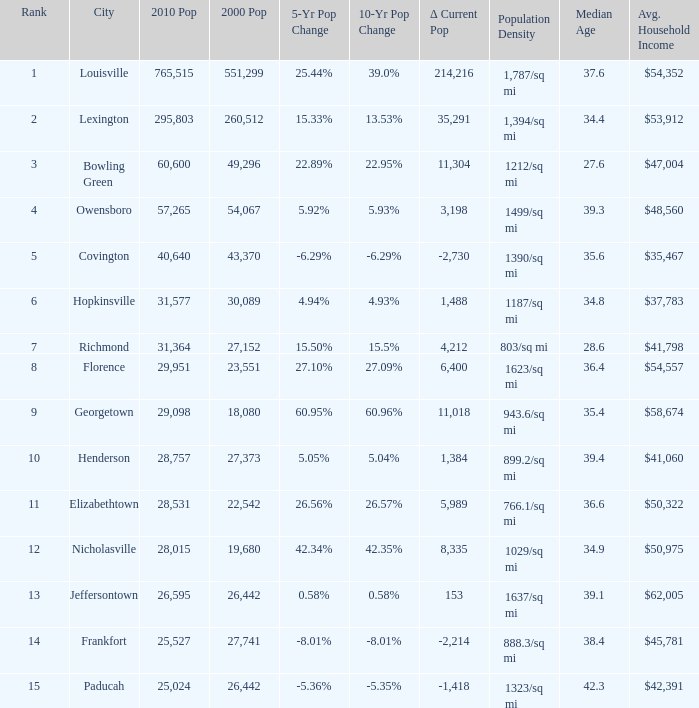What was the 2010 population of frankfort which has a rank smaller than 14? None. Could you help me parse every detail presented in this table? {'header': ['Rank', 'City', '2010 Pop', '2000 Pop', '5-Yr Pop Change', '10-Yr Pop Change', 'Δ Current Pop', 'Population Density', 'Median Age', 'Avg. Household Income '], 'rows': [['1', 'Louisville', '765,515', '551,299', '25.44%', '39.0%', '214,216', '1,787/sq mi', '37.6', '$54,352'], ['2', 'Lexington', '295,803', '260,512', '15.33%', '13.53%', '35,291', '1,394/sq mi', '34.4', '$53,912'], ['3', 'Bowling Green', '60,600', '49,296', '22.89%', '22.95%', '11,304', '1212/sq mi', '27.6', '$47,004'], ['4', 'Owensboro', '57,265', '54,067', '5.92%', '5.93%', '3,198', '1499/sq mi', '39.3', '$48,560'], ['5', 'Covington', '40,640', '43,370', '-6.29%', '-6.29%', '-2,730', '1390/sq mi', '35.6', '$35,467'], ['6', 'Hopkinsville', '31,577', '30,089', '4.94%', '4.93%', '1,488', '1187/sq mi', '34.8', '$37,783'], ['7', 'Richmond', '31,364', '27,152', '15.50%', '15.5%', '4,212', '803/sq mi', '28.6', '$41,798'], ['8', 'Florence', '29,951', '23,551', '27.10%', '27.09%', '6,400', '1623/sq mi', '36.4', '$54,557'], ['9', 'Georgetown', '29,098', '18,080', '60.95%', '60.96%', '11,018', '943.6/sq mi', '35.4', '$58,674'], ['10', 'Henderson', '28,757', '27,373', '5.05%', '5.04%', '1,384', '899.2/sq mi', '39.4', '$41,060'], ['11', 'Elizabethtown', '28,531', '22,542', '26.56%', '26.57%', '5,989', '766.1/sq mi', '36.6', '$50,322'], ['12', 'Nicholasville', '28,015', '19,680', '42.34%', '42.35%', '8,335', '1029/sq mi', '34.9', '$50,975'], ['13', 'Jeffersontown', '26,595', '26,442', '0.58%', '0.58%', '153', '1637/sq mi', '39.1', '$62,005'], ['14', 'Frankfort', '25,527', '27,741', '-8.01%', '-8.01%', '-2,214', '888.3/sq mi', '38.4', '$45,781'], ['15', 'Paducah', '25,024', '26,442', '-5.36%', '-5.35%', '-1,418', '1323/sq mi', '42.3', '$42,391']]} 